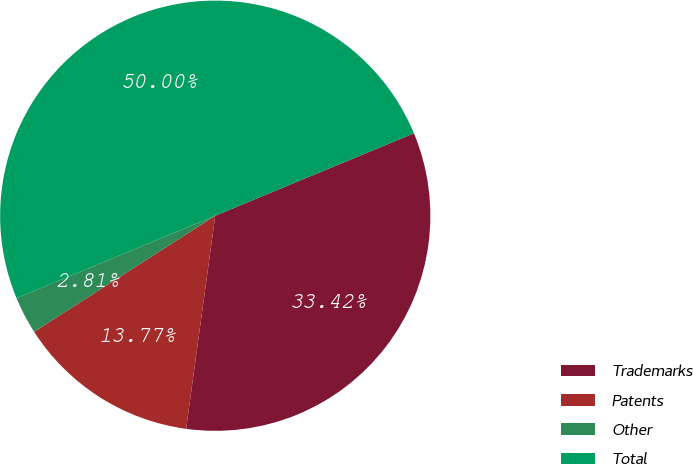Convert chart. <chart><loc_0><loc_0><loc_500><loc_500><pie_chart><fcel>Trademarks<fcel>Patents<fcel>Other<fcel>Total<nl><fcel>33.42%<fcel>13.77%<fcel>2.81%<fcel>50.0%<nl></chart> 